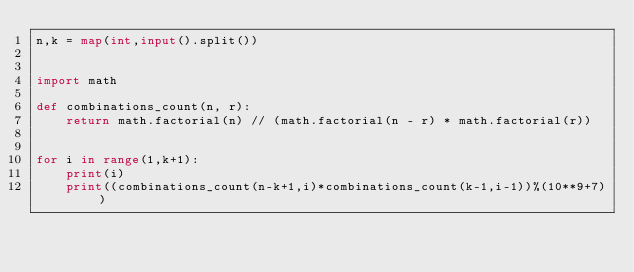Convert code to text. <code><loc_0><loc_0><loc_500><loc_500><_Python_>n,k = map(int,input().split())


import math

def combinations_count(n, r):
    return math.factorial(n) // (math.factorial(n - r) * math.factorial(r))


for i in range(1,k+1):
    print(i)
    print((combinations_count(n-k+1,i)*combinations_count(k-1,i-1))%(10**9+7))</code> 